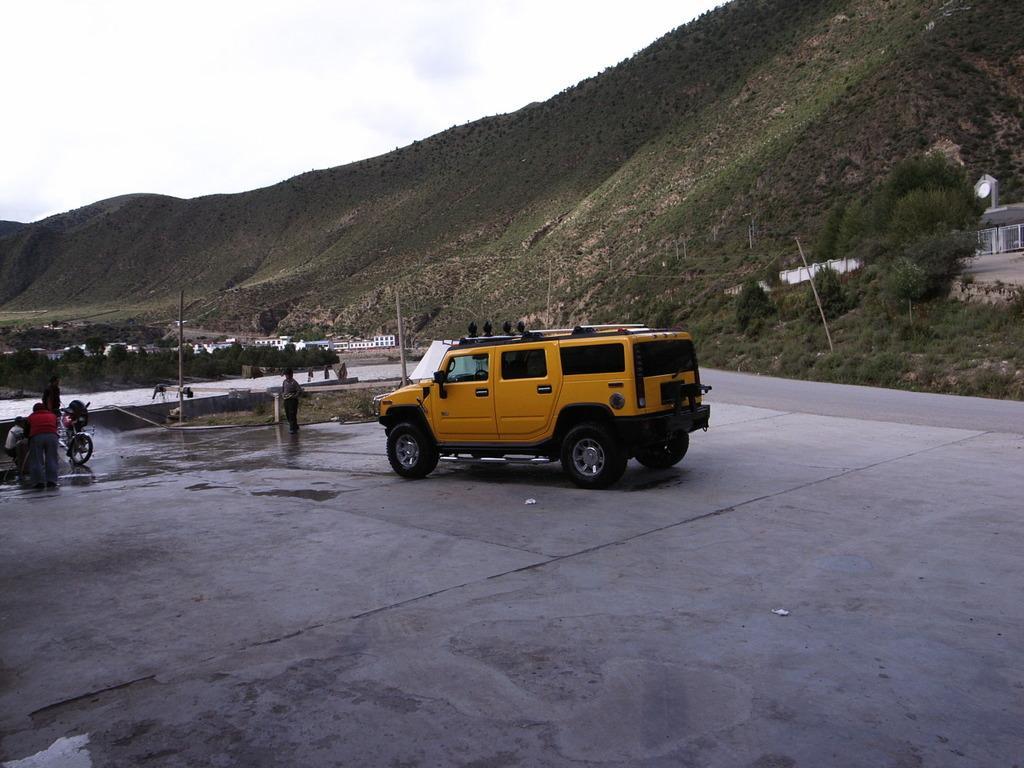Describe this image in one or two sentences. This picture shows trees and we see a hill and a car parked and we see a motorcycle and few of them are standing and we see a cloudy sky, Car is yellow in color and we see a house on the side. 